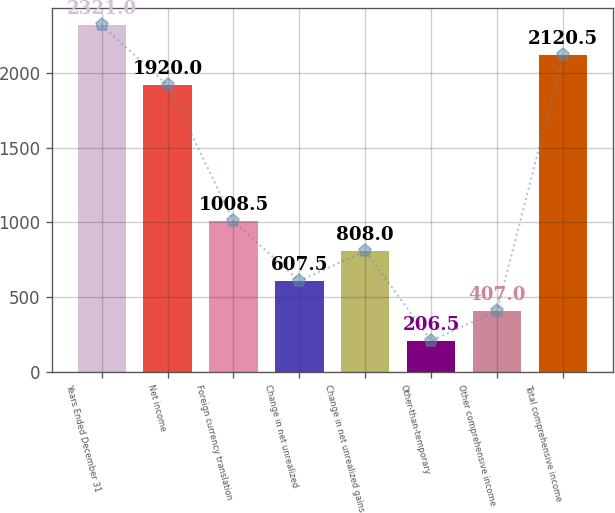<chart> <loc_0><loc_0><loc_500><loc_500><bar_chart><fcel>Years Ended December 31<fcel>Net income<fcel>Foreign currency translation<fcel>Change in net unrealized<fcel>Change in net unrealized gains<fcel>Other-than-temporary<fcel>Other comprehensive income<fcel>Total comprehensive income<nl><fcel>2321<fcel>1920<fcel>1008.5<fcel>607.5<fcel>808<fcel>206.5<fcel>407<fcel>2120.5<nl></chart> 